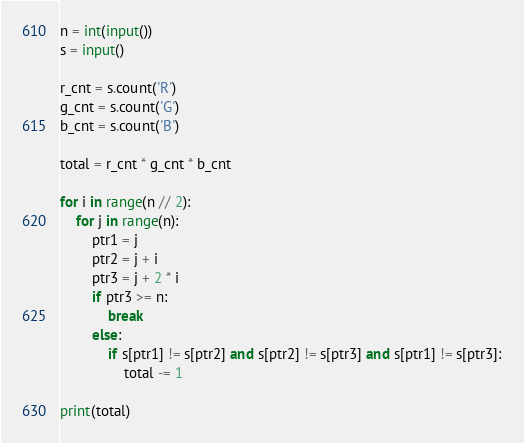<code> <loc_0><loc_0><loc_500><loc_500><_Python_>n = int(input())
s = input()

r_cnt = s.count('R')
g_cnt = s.count('G')
b_cnt = s.count('B')

total = r_cnt * g_cnt * b_cnt

for i in range(n // 2):
    for j in range(n):
        ptr1 = j
        ptr2 = j + i
        ptr3 = j + 2 * i
        if ptr3 >= n:
            break
        else:
            if s[ptr1] != s[ptr2] and s[ptr2] != s[ptr3] and s[ptr1] != s[ptr3]:
                total -= 1

print(total)
</code> 